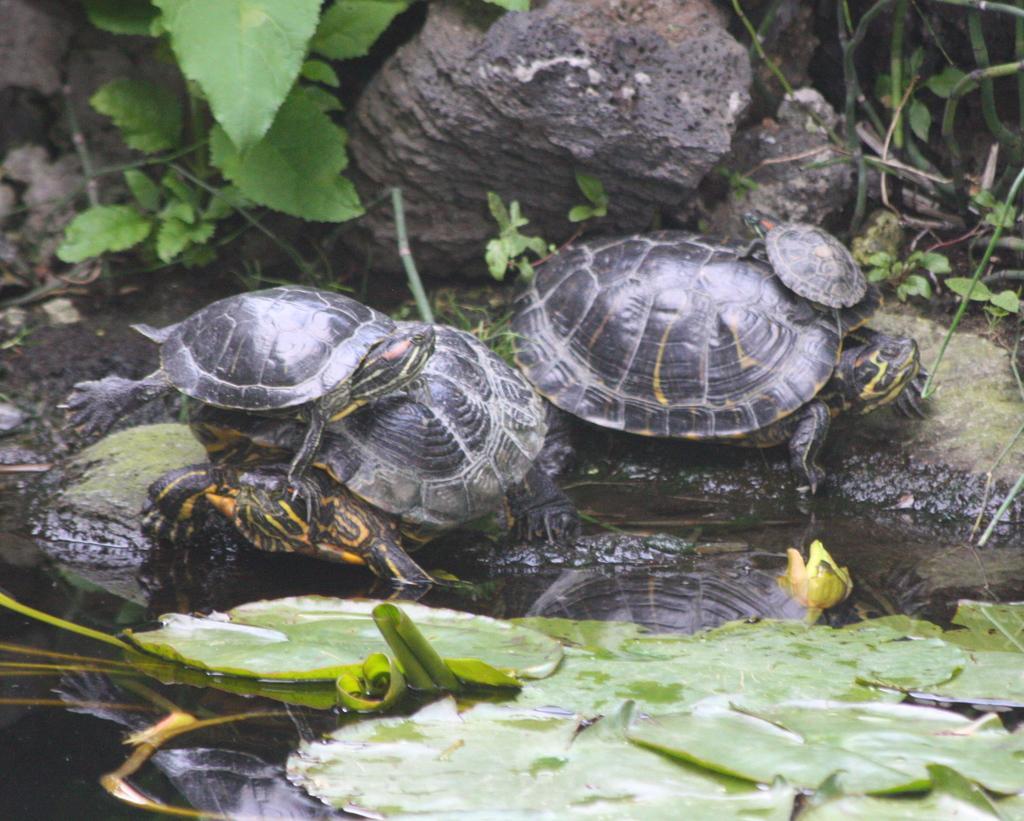Can you describe this image briefly? In this image, we can see some plants and turtles. There are rocks at the top of the image. There are some leaves on the surface of the water. 